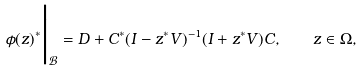Convert formula to latex. <formula><loc_0><loc_0><loc_500><loc_500>\phi ( z ) ^ { * } \Big | _ { \mathcal { B } } = D + C ^ { * } ( I - z ^ { * } V ) ^ { - 1 } ( I + z ^ { * } V ) C , \quad z \in \Omega ,</formula> 